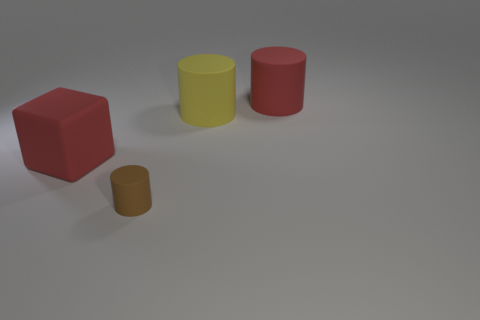Subtract all big cylinders. How many cylinders are left? 1 Add 1 tiny green matte spheres. How many objects exist? 5 Add 2 yellow things. How many yellow things exist? 3 Subtract 0 cyan blocks. How many objects are left? 4 Subtract all cubes. How many objects are left? 3 Subtract all large cylinders. Subtract all big red objects. How many objects are left? 0 Add 1 red cylinders. How many red cylinders are left? 2 